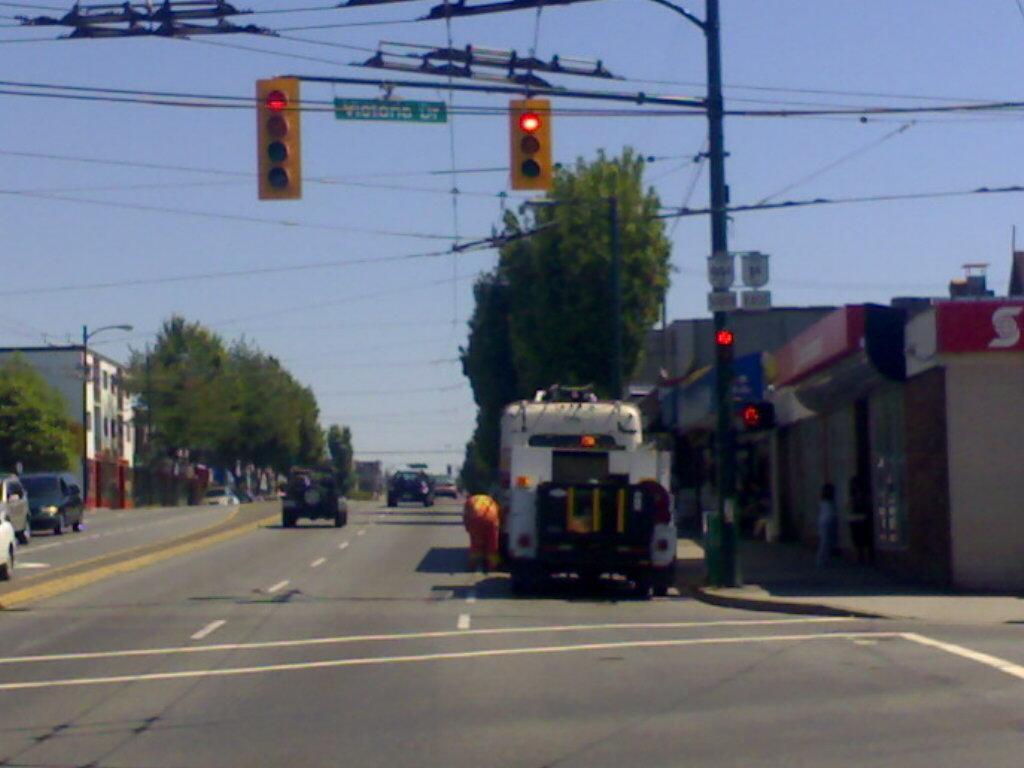Can you describe this image briefly? In this picture we can see some vehicles on the road, on the left side and right side there are buildings and trees, we can see a pole, wires, a board and traffic lights in the front, there is the sky at the top of the picture. 